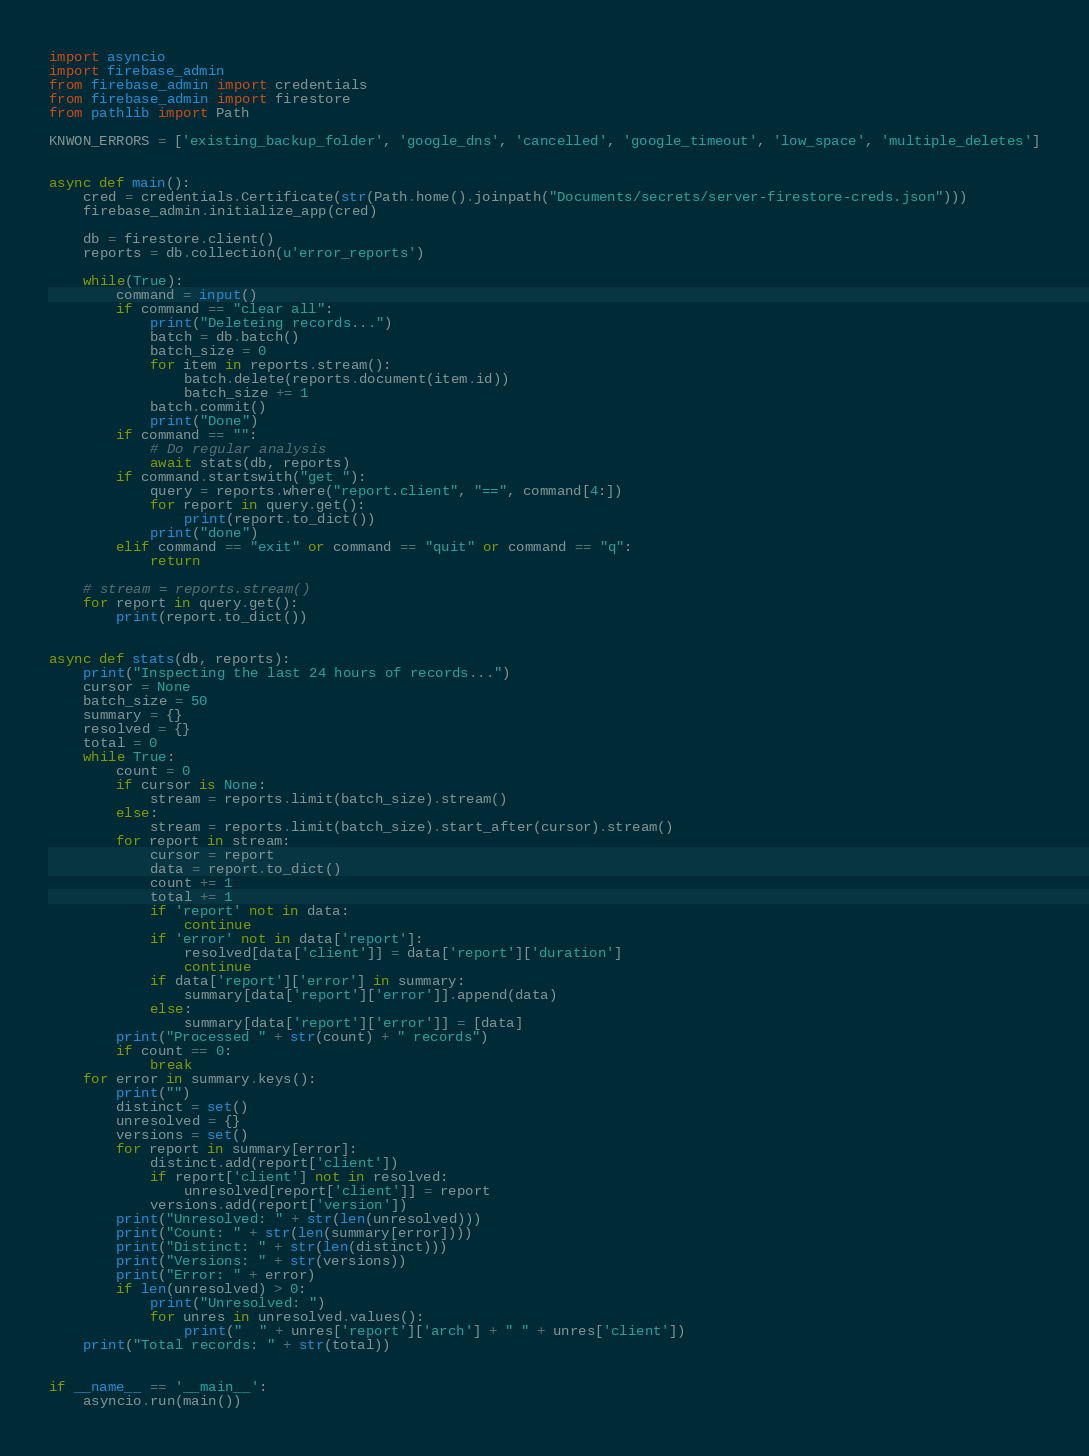<code> <loc_0><loc_0><loc_500><loc_500><_Python_>import asyncio
import firebase_admin
from firebase_admin import credentials
from firebase_admin import firestore
from pathlib import Path

KNWON_ERRORS = ['existing_backup_folder', 'google_dns', 'cancelled', 'google_timeout', 'low_space', 'multiple_deletes']


async def main():
    cred = credentials.Certificate(str(Path.home().joinpath("Documents/secrets/server-firestore-creds.json")))
    firebase_admin.initialize_app(cred)

    db = firestore.client()
    reports = db.collection(u'error_reports')

    while(True):
        command = input()
        if command == "clear all":
            print("Deleteing records...")
            batch = db.batch()
            batch_size = 0
            for item in reports.stream():
                batch.delete(reports.document(item.id))
                batch_size += 1
            batch.commit()
            print("Done")
        if command == "":
            # Do regular analysis
            await stats(db, reports)
        if command.startswith("get "):
            query = reports.where("report.client", "==", command[4:])
            for report in query.get():
                print(report.to_dict())
            print("done")
        elif command == "exit" or command == "quit" or command == "q":
            return

    # stream = reports.stream()
    for report in query.get():
        print(report.to_dict())


async def stats(db, reports):
    print("Inspecting the last 24 hours of records...")
    cursor = None
    batch_size = 50
    summary = {}
    resolved = {}
    total = 0
    while True:
        count = 0
        if cursor is None:
            stream = reports.limit(batch_size).stream()
        else:
            stream = reports.limit(batch_size).start_after(cursor).stream()
        for report in stream:
            cursor = report
            data = report.to_dict()
            count += 1
            total += 1
            if 'report' not in data:
                continue
            if 'error' not in data['report']:
                resolved[data['client']] = data['report']['duration']
                continue
            if data['report']['error'] in summary:
                summary[data['report']['error']].append(data)
            else:
                summary[data['report']['error']] = [data]
        print("Processed " + str(count) + " records")
        if count == 0:
            break
    for error in summary.keys():
        print("")
        distinct = set()
        unresolved = {}
        versions = set()
        for report in summary[error]:
            distinct.add(report['client'])
            if report['client'] not in resolved:
                unresolved[report['client']] = report
            versions.add(report['version'])
        print("Unresolved: " + str(len(unresolved)))
        print("Count: " + str(len(summary[error])))
        print("Distinct: " + str(len(distinct)))
        print("Versions: " + str(versions))
        print("Error: " + error)
        if len(unresolved) > 0:
            print("Unresolved: ")
            for unres in unresolved.values():
                print("  " + unres['report']['arch'] + " " + unres['client'])
    print("Total records: " + str(total))


if __name__ == '__main__':
    asyncio.run(main())
</code> 